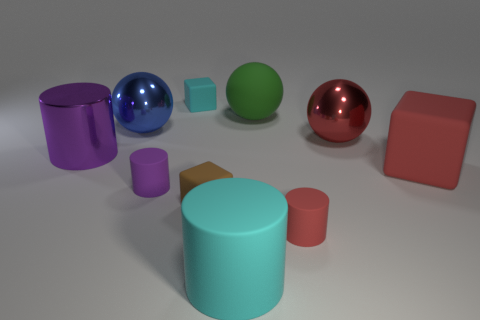Subtract all large blue metallic spheres. How many spheres are left? 2 Subtract all yellow blocks. How many purple cylinders are left? 2 Subtract 2 cylinders. How many cylinders are left? 2 Subtract all brown blocks. How many blocks are left? 2 Subtract all blocks. Subtract all purple cylinders. How many objects are left? 5 Add 2 big red metal spheres. How many big red metal spheres are left? 3 Add 2 cubes. How many cubes exist? 5 Subtract 1 cyan cylinders. How many objects are left? 9 Subtract all spheres. How many objects are left? 7 Subtract all gray cylinders. Subtract all green blocks. How many cylinders are left? 4 